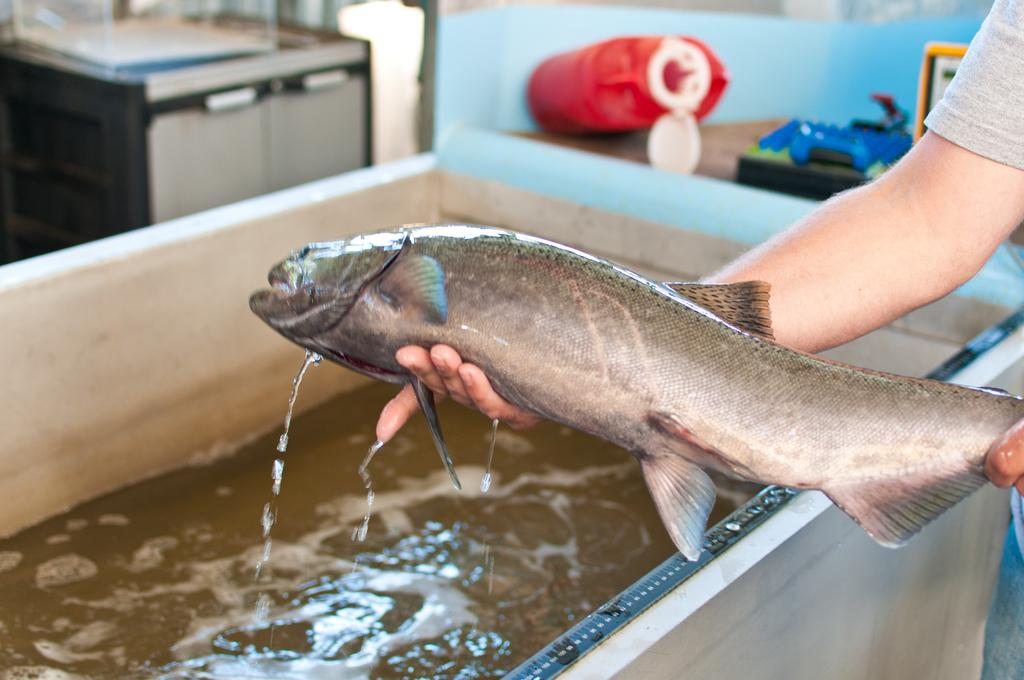What is the person in the image doing? The person is standing in the image and holding a fish in their hands. What can be seen on the table in the background of the image? There are objects on a table in the background of the image, but their specific nature is not mentioned in the facts. Can you describe the fish that the person is holding? The facts do not provide any details about the fish, so we cannot describe it further. What type of bone can be seen in the person's hand in the image? There is no bone present in the image; the person is holding a fish. Can you describe the waves in the sea in the image? There is no sea present in the image; it features a person holding a fish and a table in the background. 